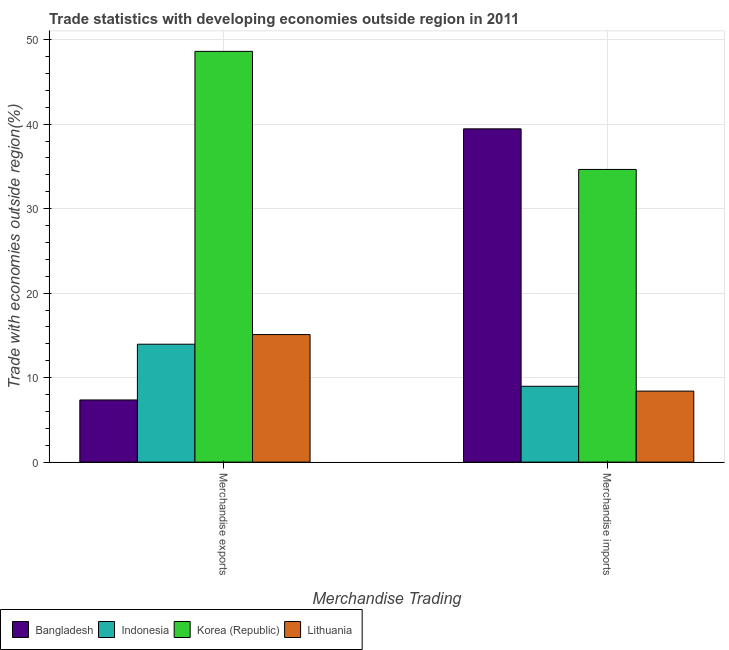How many different coloured bars are there?
Give a very brief answer. 4. How many groups of bars are there?
Keep it short and to the point. 2. Are the number of bars per tick equal to the number of legend labels?
Ensure brevity in your answer.  Yes. How many bars are there on the 1st tick from the right?
Make the answer very short. 4. What is the merchandise imports in Lithuania?
Make the answer very short. 8.41. Across all countries, what is the maximum merchandise exports?
Make the answer very short. 48.62. Across all countries, what is the minimum merchandise imports?
Ensure brevity in your answer.  8.41. In which country was the merchandise exports maximum?
Offer a very short reply. Korea (Republic). In which country was the merchandise imports minimum?
Offer a terse response. Lithuania. What is the total merchandise exports in the graph?
Offer a very short reply. 85.03. What is the difference between the merchandise exports in Korea (Republic) and that in Indonesia?
Offer a terse response. 34.66. What is the difference between the merchandise imports in Korea (Republic) and the merchandise exports in Lithuania?
Offer a terse response. 19.54. What is the average merchandise exports per country?
Ensure brevity in your answer.  21.26. What is the difference between the merchandise imports and merchandise exports in Korea (Republic)?
Provide a short and direct response. -13.98. In how many countries, is the merchandise imports greater than 2 %?
Make the answer very short. 4. What is the ratio of the merchandise exports in Indonesia to that in Bangladesh?
Offer a terse response. 1.9. In how many countries, is the merchandise imports greater than the average merchandise imports taken over all countries?
Your answer should be compact. 2. What does the 1st bar from the left in Merchandise imports represents?
Your answer should be compact. Bangladesh. What does the 1st bar from the right in Merchandise imports represents?
Ensure brevity in your answer.  Lithuania. Are all the bars in the graph horizontal?
Provide a succinct answer. No. Are the values on the major ticks of Y-axis written in scientific E-notation?
Offer a very short reply. No. Where does the legend appear in the graph?
Offer a very short reply. Bottom left. How are the legend labels stacked?
Your answer should be compact. Horizontal. What is the title of the graph?
Make the answer very short. Trade statistics with developing economies outside region in 2011. What is the label or title of the X-axis?
Provide a succinct answer. Merchandise Trading. What is the label or title of the Y-axis?
Make the answer very short. Trade with economies outside region(%). What is the Trade with economies outside region(%) of Bangladesh in Merchandise exports?
Give a very brief answer. 7.36. What is the Trade with economies outside region(%) of Indonesia in Merchandise exports?
Provide a succinct answer. 13.96. What is the Trade with economies outside region(%) of Korea (Republic) in Merchandise exports?
Your answer should be very brief. 48.62. What is the Trade with economies outside region(%) in Lithuania in Merchandise exports?
Offer a terse response. 15.1. What is the Trade with economies outside region(%) in Bangladesh in Merchandise imports?
Offer a very short reply. 39.45. What is the Trade with economies outside region(%) of Indonesia in Merchandise imports?
Your answer should be very brief. 8.98. What is the Trade with economies outside region(%) in Korea (Republic) in Merchandise imports?
Keep it short and to the point. 34.64. What is the Trade with economies outside region(%) of Lithuania in Merchandise imports?
Give a very brief answer. 8.41. Across all Merchandise Trading, what is the maximum Trade with economies outside region(%) in Bangladesh?
Provide a short and direct response. 39.45. Across all Merchandise Trading, what is the maximum Trade with economies outside region(%) of Indonesia?
Provide a succinct answer. 13.96. Across all Merchandise Trading, what is the maximum Trade with economies outside region(%) of Korea (Republic)?
Provide a short and direct response. 48.62. Across all Merchandise Trading, what is the maximum Trade with economies outside region(%) of Lithuania?
Make the answer very short. 15.1. Across all Merchandise Trading, what is the minimum Trade with economies outside region(%) of Bangladesh?
Provide a short and direct response. 7.36. Across all Merchandise Trading, what is the minimum Trade with economies outside region(%) in Indonesia?
Ensure brevity in your answer.  8.98. Across all Merchandise Trading, what is the minimum Trade with economies outside region(%) of Korea (Republic)?
Provide a succinct answer. 34.64. Across all Merchandise Trading, what is the minimum Trade with economies outside region(%) of Lithuania?
Keep it short and to the point. 8.41. What is the total Trade with economies outside region(%) in Bangladesh in the graph?
Offer a very short reply. 46.8. What is the total Trade with economies outside region(%) of Indonesia in the graph?
Provide a short and direct response. 22.93. What is the total Trade with economies outside region(%) of Korea (Republic) in the graph?
Keep it short and to the point. 83.26. What is the total Trade with economies outside region(%) in Lithuania in the graph?
Provide a short and direct response. 23.5. What is the difference between the Trade with economies outside region(%) of Bangladesh in Merchandise exports and that in Merchandise imports?
Your response must be concise. -32.09. What is the difference between the Trade with economies outside region(%) of Indonesia in Merchandise exports and that in Merchandise imports?
Provide a succinct answer. 4.98. What is the difference between the Trade with economies outside region(%) in Korea (Republic) in Merchandise exports and that in Merchandise imports?
Offer a terse response. 13.98. What is the difference between the Trade with economies outside region(%) of Lithuania in Merchandise exports and that in Merchandise imports?
Your answer should be compact. 6.69. What is the difference between the Trade with economies outside region(%) in Bangladesh in Merchandise exports and the Trade with economies outside region(%) in Indonesia in Merchandise imports?
Your answer should be compact. -1.62. What is the difference between the Trade with economies outside region(%) in Bangladesh in Merchandise exports and the Trade with economies outside region(%) in Korea (Republic) in Merchandise imports?
Give a very brief answer. -27.28. What is the difference between the Trade with economies outside region(%) of Bangladesh in Merchandise exports and the Trade with economies outside region(%) of Lithuania in Merchandise imports?
Ensure brevity in your answer.  -1.05. What is the difference between the Trade with economies outside region(%) of Indonesia in Merchandise exports and the Trade with economies outside region(%) of Korea (Republic) in Merchandise imports?
Make the answer very short. -20.68. What is the difference between the Trade with economies outside region(%) in Indonesia in Merchandise exports and the Trade with economies outside region(%) in Lithuania in Merchandise imports?
Keep it short and to the point. 5.55. What is the difference between the Trade with economies outside region(%) in Korea (Republic) in Merchandise exports and the Trade with economies outside region(%) in Lithuania in Merchandise imports?
Your answer should be very brief. 40.21. What is the average Trade with economies outside region(%) of Bangladesh per Merchandise Trading?
Your answer should be compact. 23.4. What is the average Trade with economies outside region(%) of Indonesia per Merchandise Trading?
Ensure brevity in your answer.  11.47. What is the average Trade with economies outside region(%) of Korea (Republic) per Merchandise Trading?
Offer a terse response. 41.63. What is the average Trade with economies outside region(%) in Lithuania per Merchandise Trading?
Keep it short and to the point. 11.75. What is the difference between the Trade with economies outside region(%) of Bangladesh and Trade with economies outside region(%) of Indonesia in Merchandise exports?
Offer a terse response. -6.6. What is the difference between the Trade with economies outside region(%) of Bangladesh and Trade with economies outside region(%) of Korea (Republic) in Merchandise exports?
Your answer should be compact. -41.26. What is the difference between the Trade with economies outside region(%) of Bangladesh and Trade with economies outside region(%) of Lithuania in Merchandise exports?
Offer a very short reply. -7.74. What is the difference between the Trade with economies outside region(%) of Indonesia and Trade with economies outside region(%) of Korea (Republic) in Merchandise exports?
Ensure brevity in your answer.  -34.66. What is the difference between the Trade with economies outside region(%) in Indonesia and Trade with economies outside region(%) in Lithuania in Merchandise exports?
Provide a short and direct response. -1.14. What is the difference between the Trade with economies outside region(%) in Korea (Republic) and Trade with economies outside region(%) in Lithuania in Merchandise exports?
Your answer should be very brief. 33.52. What is the difference between the Trade with economies outside region(%) of Bangladesh and Trade with economies outside region(%) of Indonesia in Merchandise imports?
Provide a succinct answer. 30.47. What is the difference between the Trade with economies outside region(%) of Bangladesh and Trade with economies outside region(%) of Korea (Republic) in Merchandise imports?
Offer a very short reply. 4.81. What is the difference between the Trade with economies outside region(%) in Bangladesh and Trade with economies outside region(%) in Lithuania in Merchandise imports?
Offer a very short reply. 31.04. What is the difference between the Trade with economies outside region(%) of Indonesia and Trade with economies outside region(%) of Korea (Republic) in Merchandise imports?
Offer a very short reply. -25.66. What is the difference between the Trade with economies outside region(%) of Indonesia and Trade with economies outside region(%) of Lithuania in Merchandise imports?
Provide a short and direct response. 0.57. What is the difference between the Trade with economies outside region(%) of Korea (Republic) and Trade with economies outside region(%) of Lithuania in Merchandise imports?
Your answer should be compact. 26.23. What is the ratio of the Trade with economies outside region(%) in Bangladesh in Merchandise exports to that in Merchandise imports?
Give a very brief answer. 0.19. What is the ratio of the Trade with economies outside region(%) of Indonesia in Merchandise exports to that in Merchandise imports?
Your answer should be very brief. 1.55. What is the ratio of the Trade with economies outside region(%) of Korea (Republic) in Merchandise exports to that in Merchandise imports?
Offer a very short reply. 1.4. What is the ratio of the Trade with economies outside region(%) of Lithuania in Merchandise exports to that in Merchandise imports?
Provide a succinct answer. 1.8. What is the difference between the highest and the second highest Trade with economies outside region(%) in Bangladesh?
Give a very brief answer. 32.09. What is the difference between the highest and the second highest Trade with economies outside region(%) of Indonesia?
Give a very brief answer. 4.98. What is the difference between the highest and the second highest Trade with economies outside region(%) of Korea (Republic)?
Your answer should be compact. 13.98. What is the difference between the highest and the second highest Trade with economies outside region(%) in Lithuania?
Keep it short and to the point. 6.69. What is the difference between the highest and the lowest Trade with economies outside region(%) in Bangladesh?
Your answer should be compact. 32.09. What is the difference between the highest and the lowest Trade with economies outside region(%) of Indonesia?
Your answer should be very brief. 4.98. What is the difference between the highest and the lowest Trade with economies outside region(%) in Korea (Republic)?
Ensure brevity in your answer.  13.98. What is the difference between the highest and the lowest Trade with economies outside region(%) of Lithuania?
Ensure brevity in your answer.  6.69. 